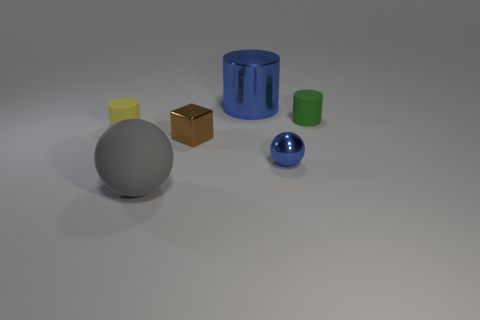There is a gray object that is the same size as the shiny cylinder; what shape is it?
Provide a succinct answer. Sphere. Does the ball that is right of the gray object have the same size as the rubber cylinder left of the blue metal cylinder?
Ensure brevity in your answer.  Yes. What color is the sphere that is the same material as the block?
Ensure brevity in your answer.  Blue. Are the blue object that is behind the tiny brown shiny thing and the large thing in front of the large shiny cylinder made of the same material?
Provide a succinct answer. No. Are there any brown cubes that have the same size as the yellow rubber cylinder?
Give a very brief answer. Yes. There is a cylinder that is behind the small rubber object right of the blue cylinder; what is its size?
Provide a succinct answer. Large. What number of large metal cylinders have the same color as the metallic ball?
Your answer should be very brief. 1. There is a blue thing in front of the rubber thing that is on the left side of the gray thing; what shape is it?
Offer a terse response. Sphere. What number of tiny blocks are the same material as the small yellow cylinder?
Provide a short and direct response. 0. There is a small cylinder that is to the right of the yellow rubber cylinder; what is it made of?
Your response must be concise. Rubber. 